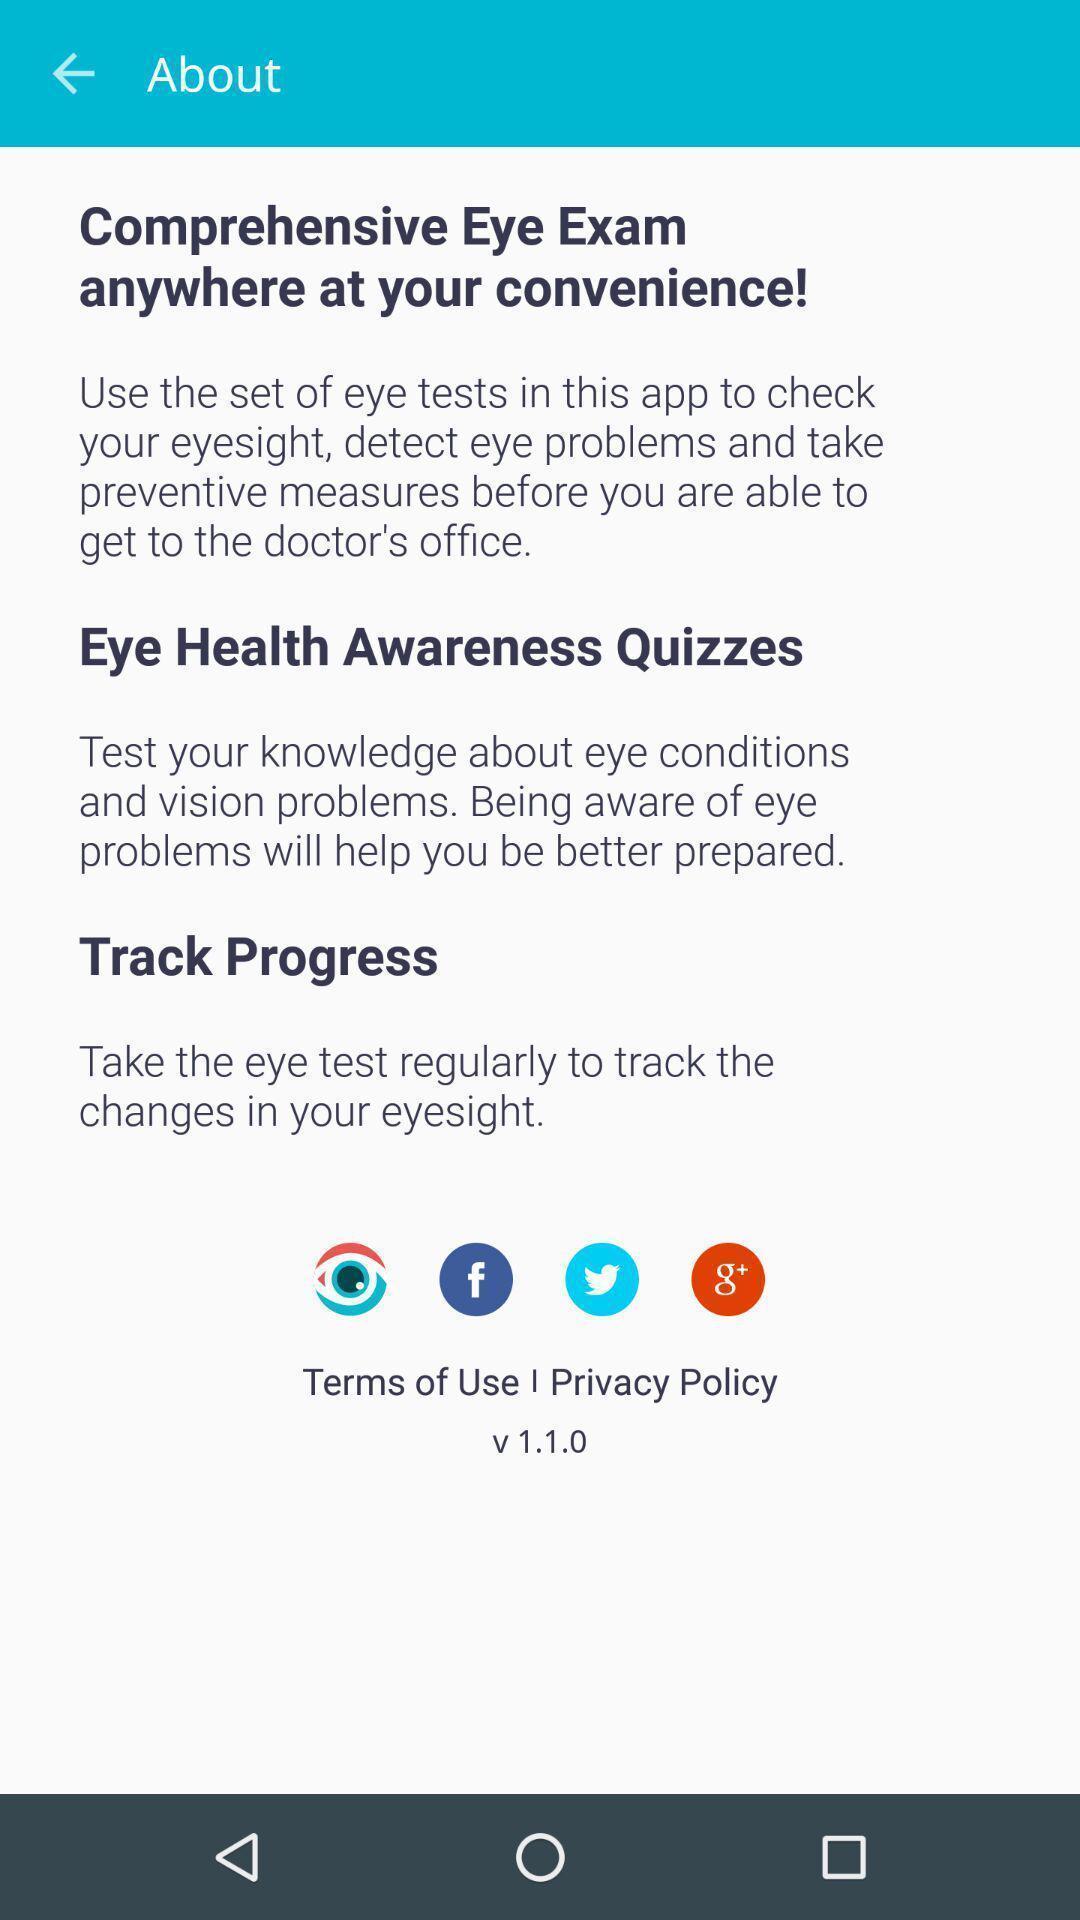Please provide a description for this image. Screen displaying the about page. 